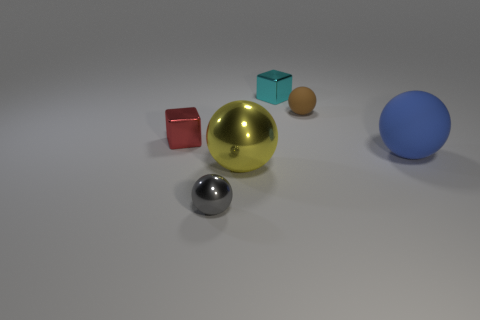There is a object that is both to the left of the yellow thing and in front of the blue sphere; what shape is it?
Make the answer very short. Sphere. What number of tiny rubber things have the same color as the big metallic ball?
Keep it short and to the point. 0. There is a matte thing that is in front of the cube in front of the small brown object; are there any small cyan shiny things that are in front of it?
Offer a terse response. No. How big is the shiny object that is to the right of the small gray shiny thing and in front of the tiny red cube?
Your answer should be compact. Large. What number of big spheres have the same material as the cyan object?
Offer a very short reply. 1. What number of cylinders are either brown objects or blue matte objects?
Your answer should be compact. 0. There is a red shiny thing that is in front of the small cube that is right of the small metallic thing that is on the left side of the gray shiny object; what size is it?
Ensure brevity in your answer.  Small. There is a tiny object that is both right of the red block and left of the big yellow thing; what color is it?
Provide a succinct answer. Gray. There is a gray metal ball; does it have the same size as the metal object that is behind the tiny brown sphere?
Ensure brevity in your answer.  Yes. There is another large rubber thing that is the same shape as the brown object; what is its color?
Your response must be concise. Blue. 